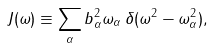<formula> <loc_0><loc_0><loc_500><loc_500>J ( \omega ) \equiv \sum _ { \alpha } b _ { \alpha } ^ { 2 } \omega _ { \alpha } \, \delta ( \omega ^ { 2 } - \omega _ { \alpha } ^ { 2 } ) ,</formula> 